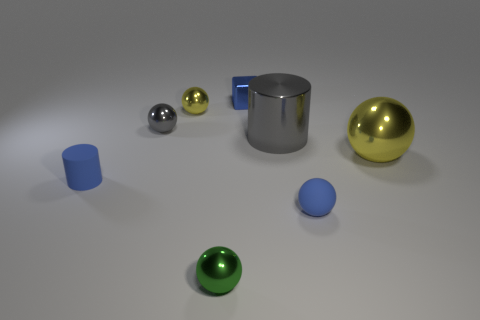Subtract all small balls. How many balls are left? 1 Add 2 blue matte balls. How many objects exist? 10 Subtract all cylinders. How many objects are left? 6 Subtract all blue cylinders. How many cylinders are left? 1 Subtract all brown blocks. How many yellow balls are left? 2 Subtract 3 spheres. How many spheres are left? 2 Subtract all yellow balls. Subtract all blue blocks. How many balls are left? 3 Subtract all tiny red cubes. Subtract all tiny gray metallic spheres. How many objects are left? 7 Add 4 big yellow shiny objects. How many big yellow shiny objects are left? 5 Add 4 big gray things. How many big gray things exist? 5 